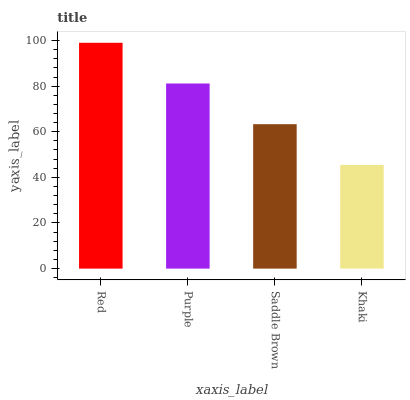Is Khaki the minimum?
Answer yes or no. Yes. Is Red the maximum?
Answer yes or no. Yes. Is Purple the minimum?
Answer yes or no. No. Is Purple the maximum?
Answer yes or no. No. Is Red greater than Purple?
Answer yes or no. Yes. Is Purple less than Red?
Answer yes or no. Yes. Is Purple greater than Red?
Answer yes or no. No. Is Red less than Purple?
Answer yes or no. No. Is Purple the high median?
Answer yes or no. Yes. Is Saddle Brown the low median?
Answer yes or no. Yes. Is Khaki the high median?
Answer yes or no. No. Is Red the low median?
Answer yes or no. No. 